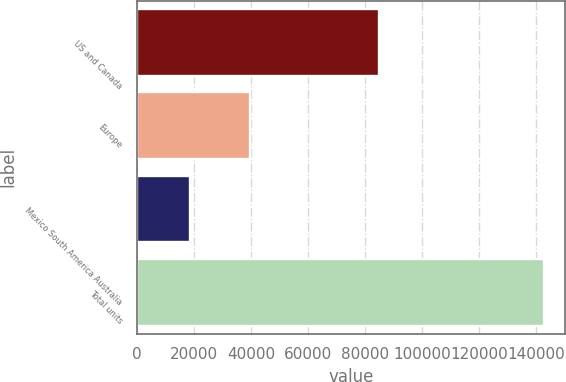Convert chart to OTSL. <chart><loc_0><loc_0><loc_500><loc_500><bar_chart><fcel>US and Canada<fcel>Europe<fcel>Mexico South America Australia<fcel>Total units<nl><fcel>84800<fcel>39500<fcel>18600<fcel>142900<nl></chart> 